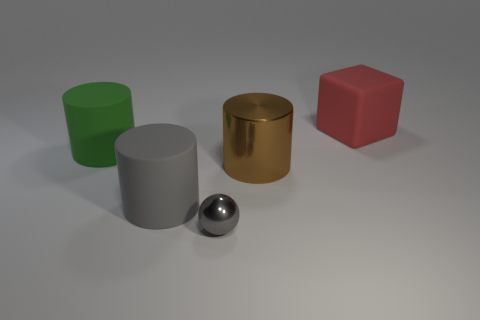Add 2 small brown spheres. How many objects exist? 7 Subtract all big rubber cylinders. How many cylinders are left? 1 Subtract all brown cylinders. How many cylinders are left? 2 Subtract all blocks. How many objects are left? 4 Subtract 1 cylinders. How many cylinders are left? 2 Subtract all big brown cylinders. Subtract all brown things. How many objects are left? 3 Add 3 gray rubber cylinders. How many gray rubber cylinders are left? 4 Add 5 small blue matte things. How many small blue matte things exist? 5 Subtract 0 cyan cylinders. How many objects are left? 5 Subtract all purple spheres. Subtract all green cylinders. How many spheres are left? 1 